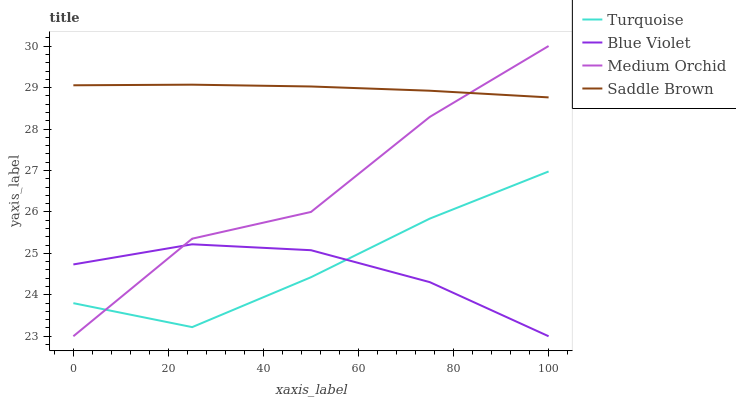Does Blue Violet have the minimum area under the curve?
Answer yes or no. Yes. Does Saddle Brown have the maximum area under the curve?
Answer yes or no. Yes. Does Medium Orchid have the minimum area under the curve?
Answer yes or no. No. Does Medium Orchid have the maximum area under the curve?
Answer yes or no. No. Is Saddle Brown the smoothest?
Answer yes or no. Yes. Is Medium Orchid the roughest?
Answer yes or no. Yes. Is Medium Orchid the smoothest?
Answer yes or no. No. Is Saddle Brown the roughest?
Answer yes or no. No. Does Saddle Brown have the lowest value?
Answer yes or no. No. Does Medium Orchid have the highest value?
Answer yes or no. Yes. Does Saddle Brown have the highest value?
Answer yes or no. No. Is Turquoise less than Saddle Brown?
Answer yes or no. Yes. Is Saddle Brown greater than Blue Violet?
Answer yes or no. Yes. Does Blue Violet intersect Medium Orchid?
Answer yes or no. Yes. Is Blue Violet less than Medium Orchid?
Answer yes or no. No. Is Blue Violet greater than Medium Orchid?
Answer yes or no. No. Does Turquoise intersect Saddle Brown?
Answer yes or no. No. 